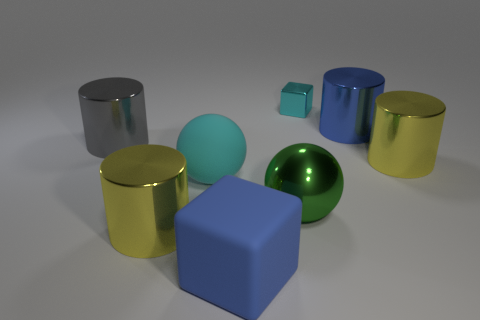Subtract all big gray cylinders. How many cylinders are left? 3 Subtract 1 spheres. How many spheres are left? 1 Subtract all yellow cylinders. How many cylinders are left? 2 Subtract all balls. How many objects are left? 6 Subtract all gray cylinders. How many green balls are left? 1 Subtract all small metal objects. Subtract all rubber cubes. How many objects are left? 6 Add 3 yellow cylinders. How many yellow cylinders are left? 5 Add 4 large yellow shiny objects. How many large yellow shiny objects exist? 6 Add 2 large matte cylinders. How many objects exist? 10 Subtract 0 cyan cylinders. How many objects are left? 8 